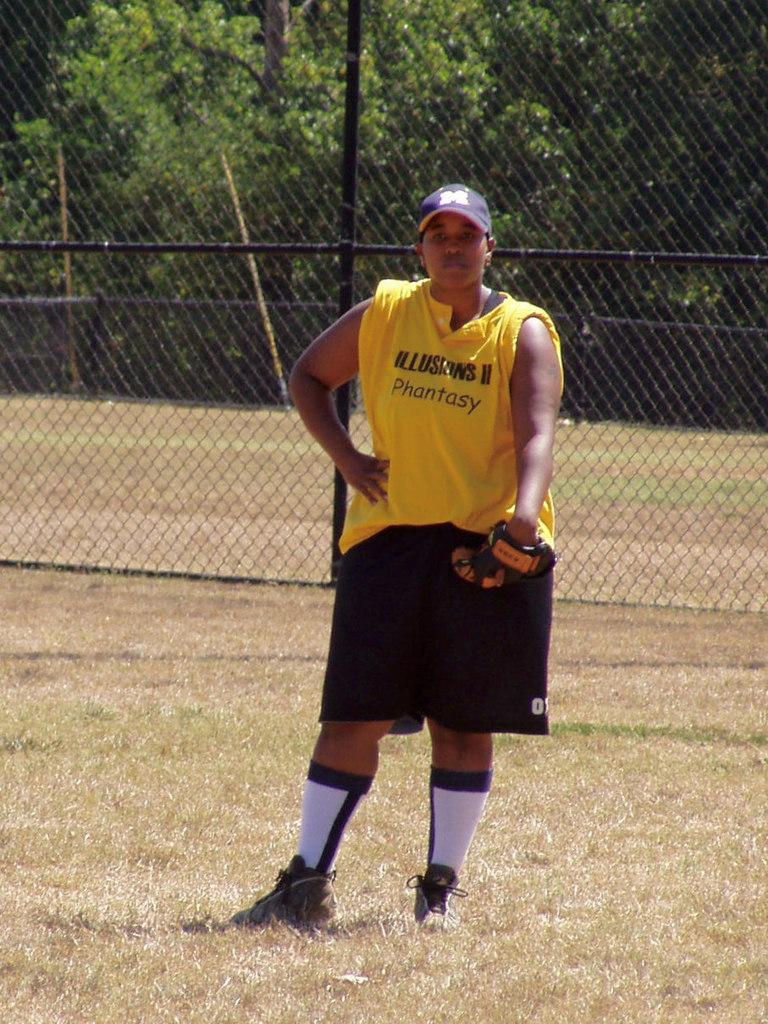<image>
Give a short and clear explanation of the subsequent image. A boy with a catcher's mitt is standing in a field and his shirt says Phantasy. 